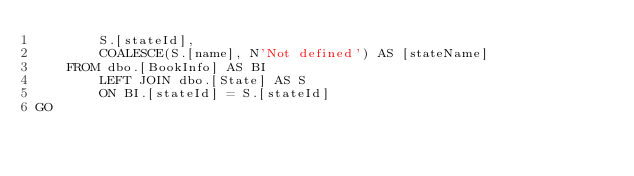Convert code to text. <code><loc_0><loc_0><loc_500><loc_500><_SQL_>        S.[stateId],
        COALESCE(S.[name], N'Not defined') AS [stateName]
    FROM dbo.[BookInfo] AS BI
        LEFT JOIN dbo.[State] AS S
        ON BI.[stateId] = S.[stateId]
GO</code> 